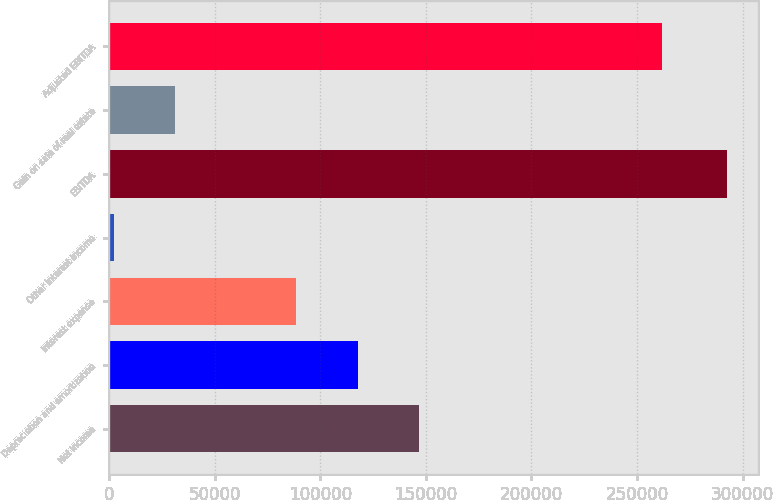<chart> <loc_0><loc_0><loc_500><loc_500><bar_chart><fcel>Net income<fcel>Depreciation and amortization<fcel>Interest expense<fcel>Other interest income<fcel>EBITDA<fcel>Gain on sale of real estate<fcel>Adjusted EBITDA<nl><fcel>146616<fcel>117591<fcel>88566<fcel>2216<fcel>292465<fcel>31240.9<fcel>261717<nl></chart> 